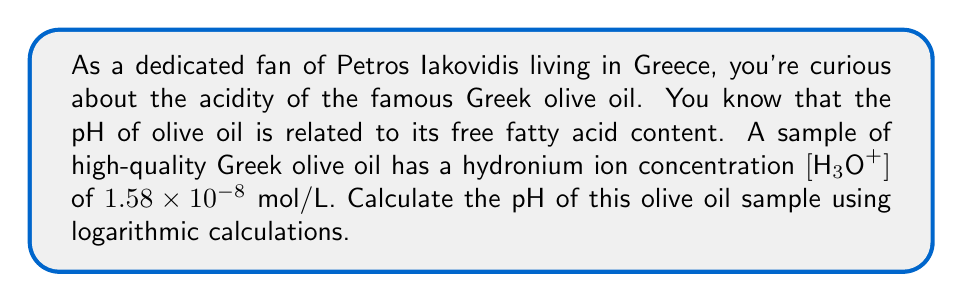Teach me how to tackle this problem. To solve this problem, we'll use the definition of pH and the properties of logarithms:

1) The pH is defined as the negative logarithm (base 10) of the hydronium ion concentration:

   $$ pH = -\log_{10}[H_3O^+] $$

2) We're given that $[H_3O^+] = 1.58 \times 10^{-8}$ mol/L

3) Substituting this into the pH equation:

   $$ pH = -\log_{10}(1.58 \times 10^{-8}) $$

4) Using the properties of logarithms, we can split this into two terms:

   $$ pH = -(\log_{10}(1.58) + \log_{10}(10^{-8})) $$

5) Simplify:
   $$ pH = -(\log_{10}(1.58) - 8) $$

6) Calculate $\log_{10}(1.58)$ (you can use a calculator for this):

   $$ pH = -(0.19866 - 8) $$

7) Simplify:
   $$ pH = -0.19866 + 8 = 7.80134 $$

8) Rounding to two decimal places:

   $$ pH \approx 7.80 $$

This pH value indicates that the olive oil is slightly basic, which is typical for high-quality olive oil.
Answer: The pH of the Greek olive oil sample is approximately 7.80. 